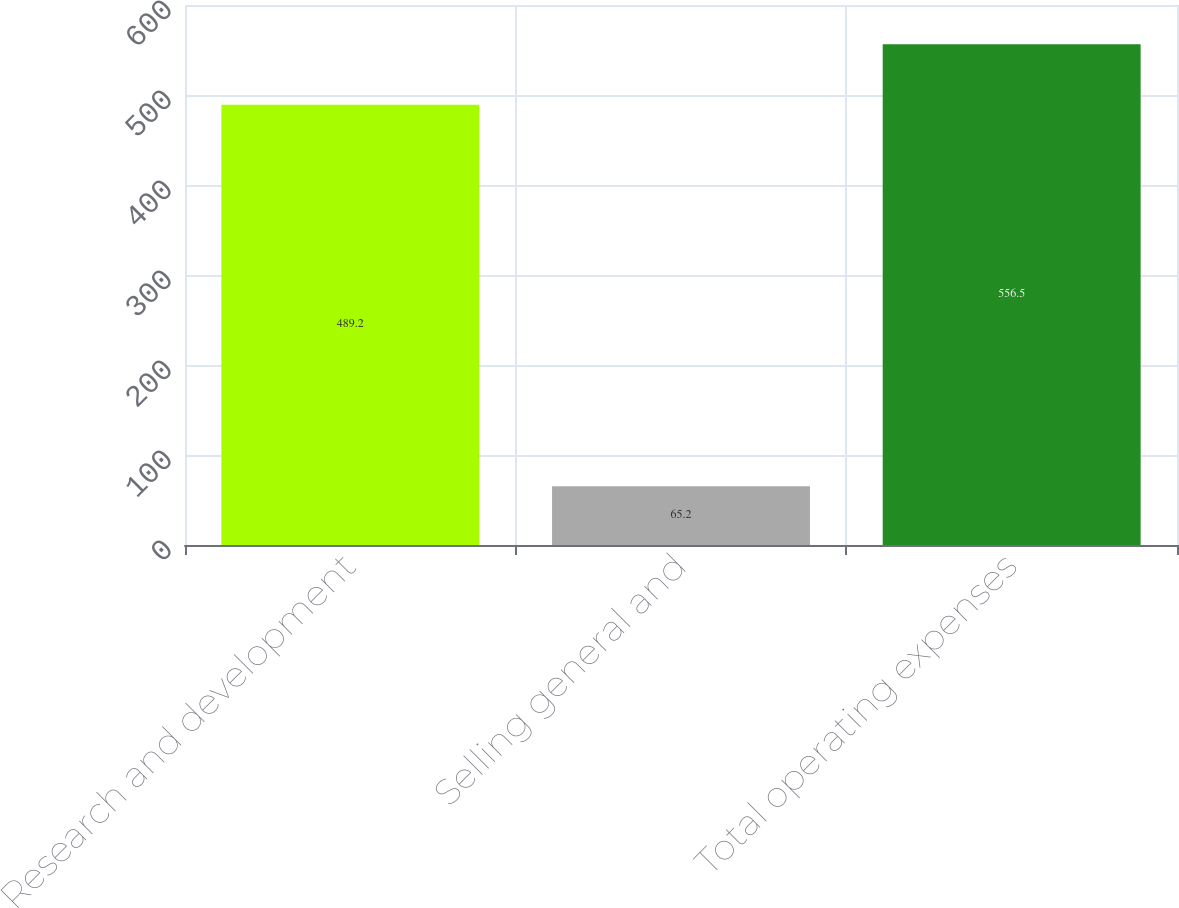Convert chart to OTSL. <chart><loc_0><loc_0><loc_500><loc_500><bar_chart><fcel>Research and development<fcel>Selling general and<fcel>Total operating expenses<nl><fcel>489.2<fcel>65.2<fcel>556.5<nl></chart> 